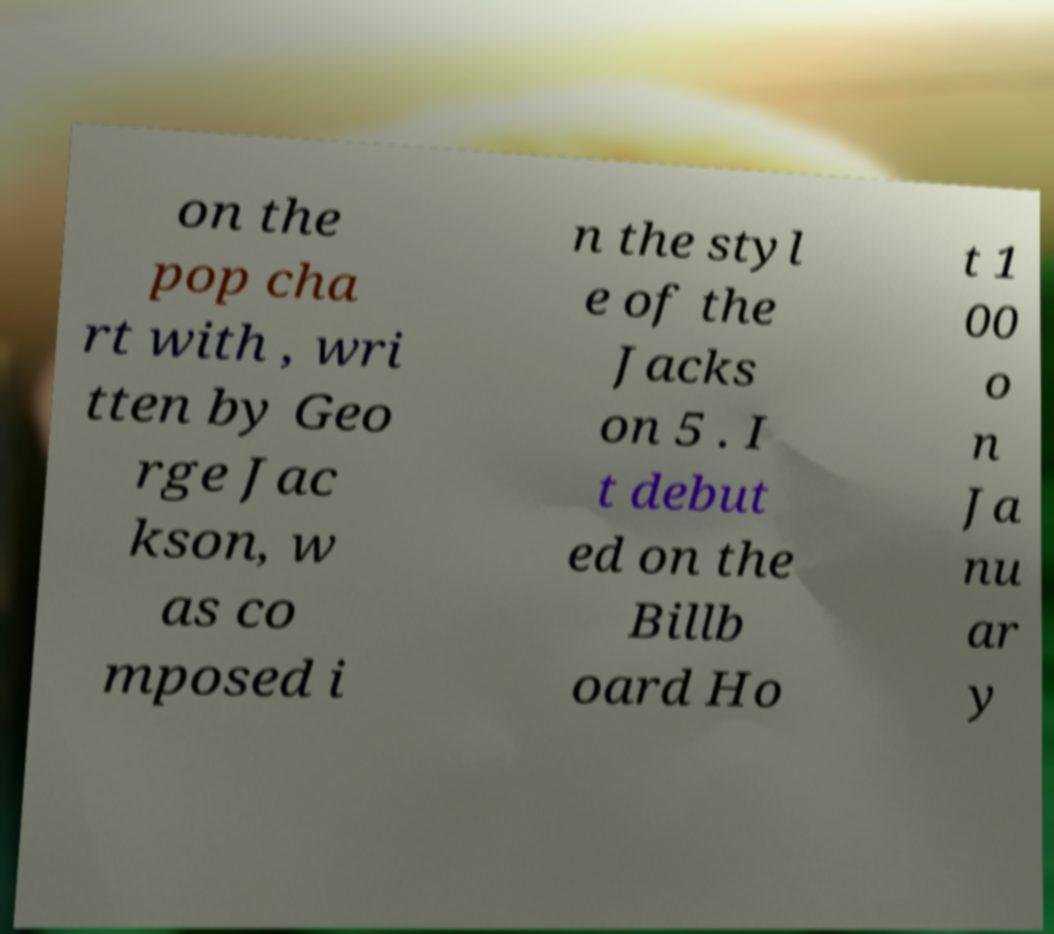For documentation purposes, I need the text within this image transcribed. Could you provide that? on the pop cha rt with , wri tten by Geo rge Jac kson, w as co mposed i n the styl e of the Jacks on 5 . I t debut ed on the Billb oard Ho t 1 00 o n Ja nu ar y 